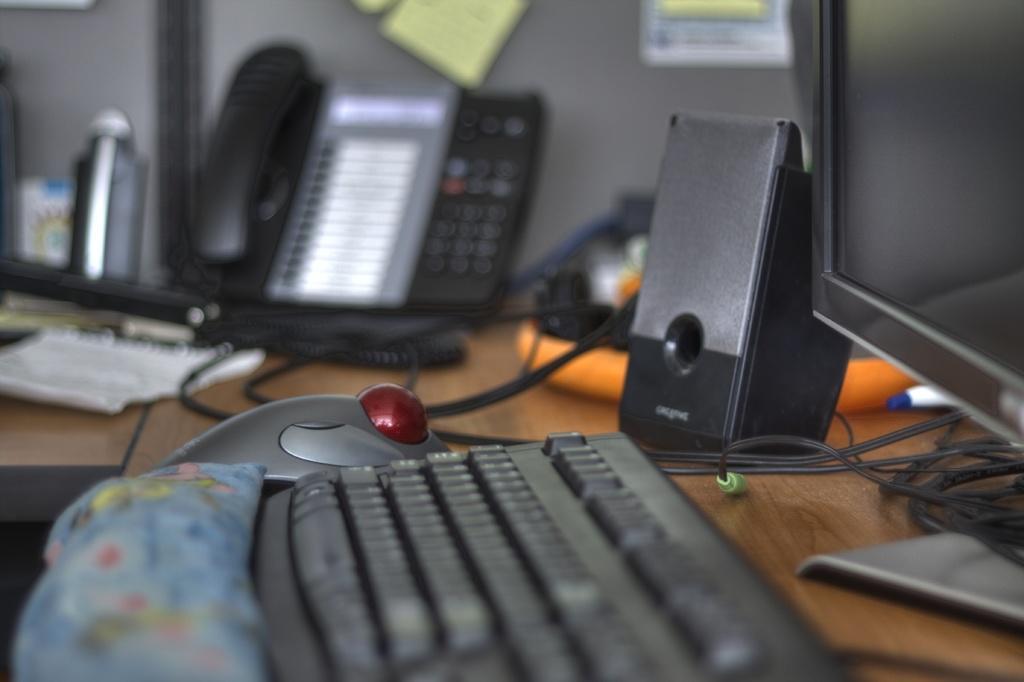How would you summarize this image in a sentence or two? In this picture we can see a table. On the table there is a monitor, keyboard, mouse, and a phone. 